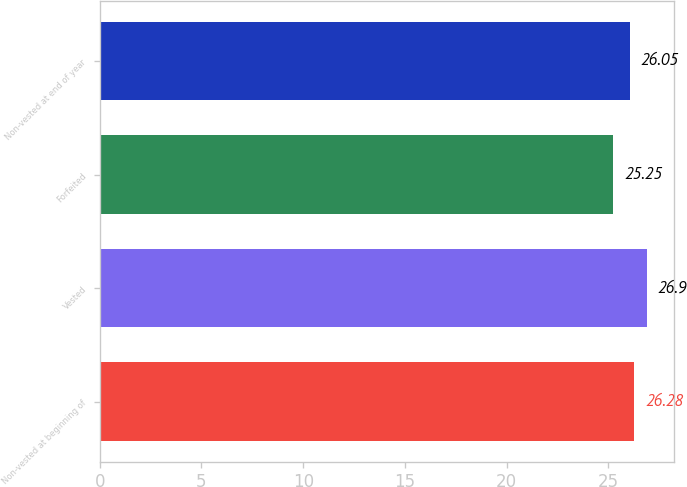<chart> <loc_0><loc_0><loc_500><loc_500><bar_chart><fcel>Non-vested at beginning of<fcel>Vested<fcel>Forfeited<fcel>Non-vested at end of year<nl><fcel>26.28<fcel>26.9<fcel>25.25<fcel>26.05<nl></chart> 